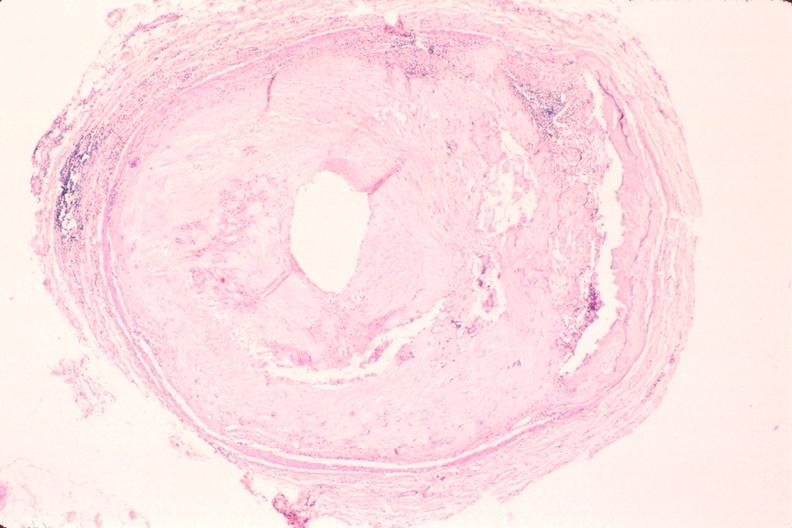what is present?
Answer the question using a single word or phrase. Vasculature 